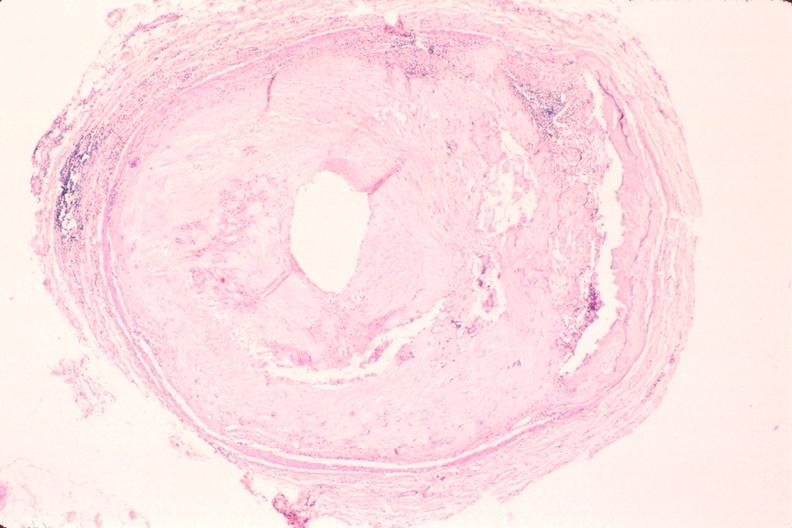what is present?
Answer the question using a single word or phrase. Vasculature 